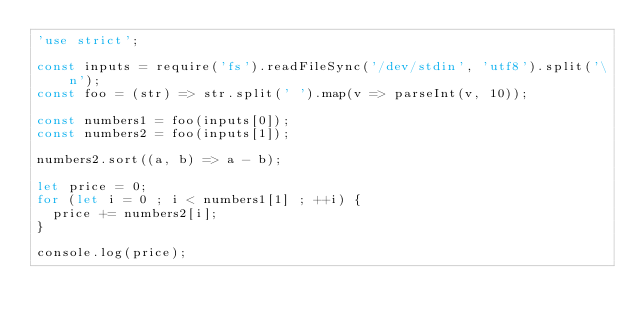Convert code to text. <code><loc_0><loc_0><loc_500><loc_500><_JavaScript_>'use strict';

const inputs = require('fs').readFileSync('/dev/stdin', 'utf8').split('\n');
const foo = (str) => str.split(' ').map(v => parseInt(v, 10));

const numbers1 = foo(inputs[0]);
const numbers2 = foo(inputs[1]);

numbers2.sort((a, b) => a - b);

let price = 0;
for (let i = 0 ; i < numbers1[1] ; ++i) {
  price += numbers2[i];
}

console.log(price);</code> 